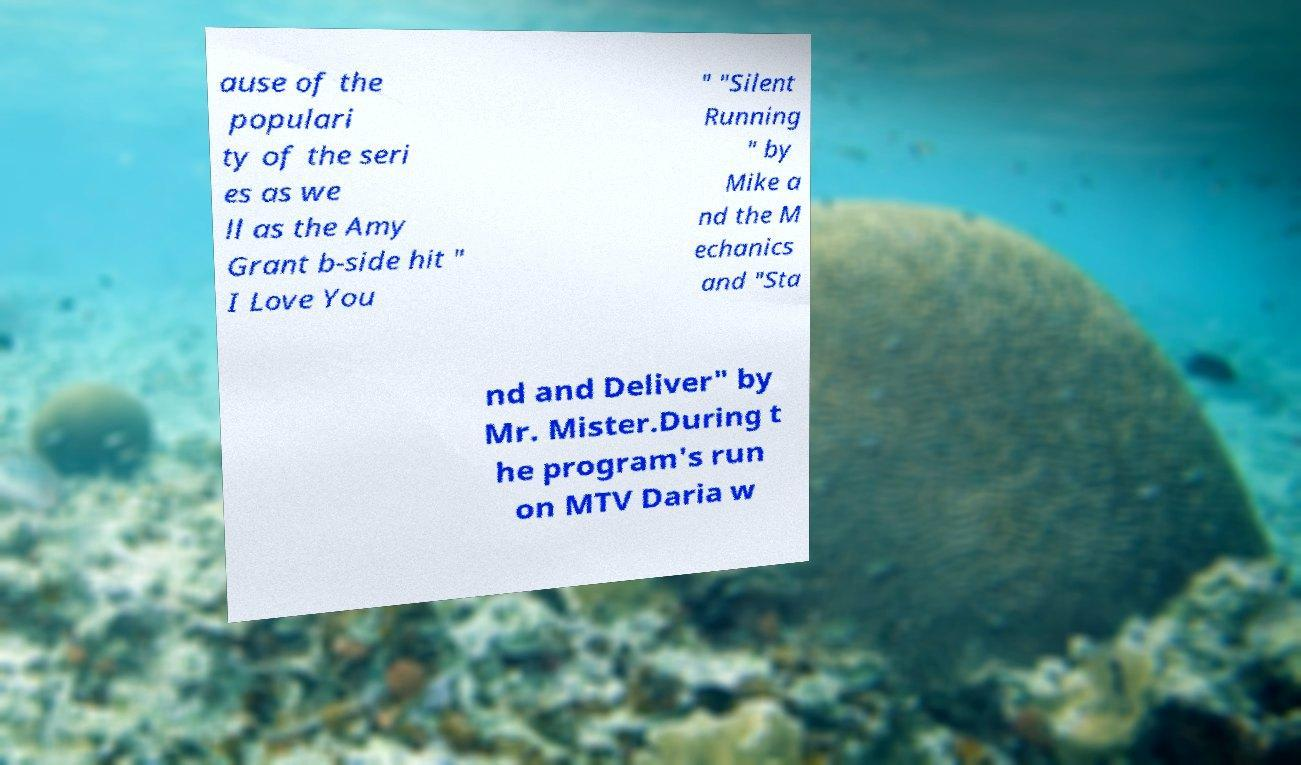Can you read and provide the text displayed in the image?This photo seems to have some interesting text. Can you extract and type it out for me? ause of the populari ty of the seri es as we ll as the Amy Grant b-side hit " I Love You " "Silent Running " by Mike a nd the M echanics and "Sta nd and Deliver" by Mr. Mister.During t he program's run on MTV Daria w 